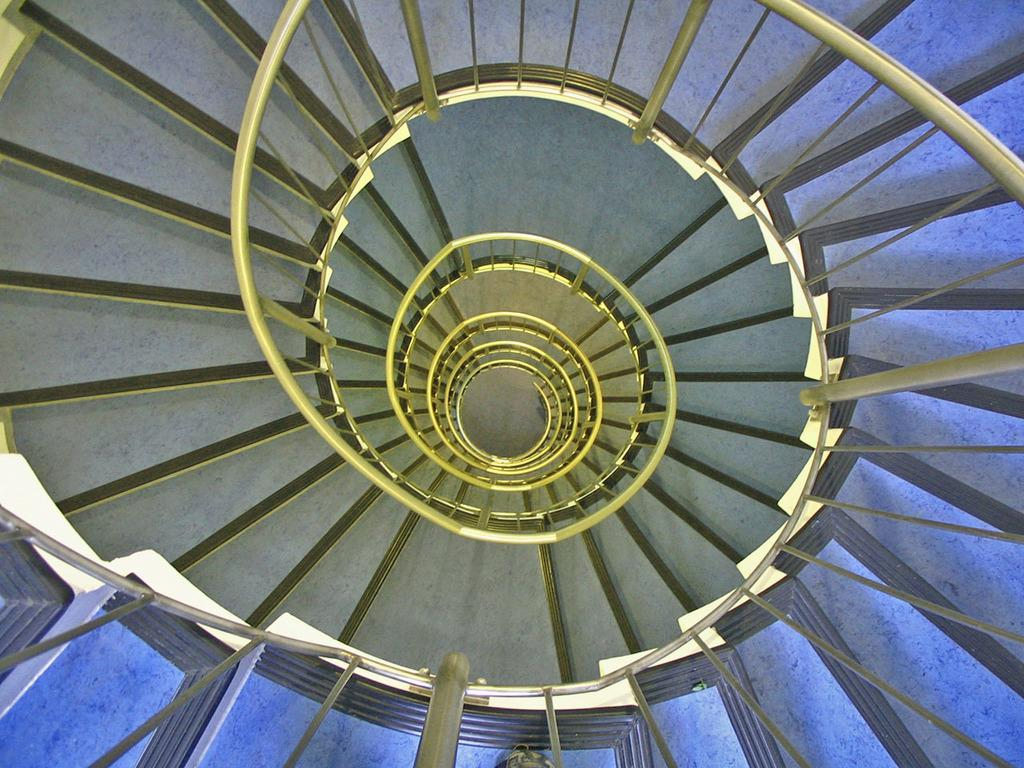What is the main subject in the center of the image? There is a staircase in the center of the image. How many laborers are working on the camp in the image? There is no reference to laborers or a camp in the image; it only features a staircase. 